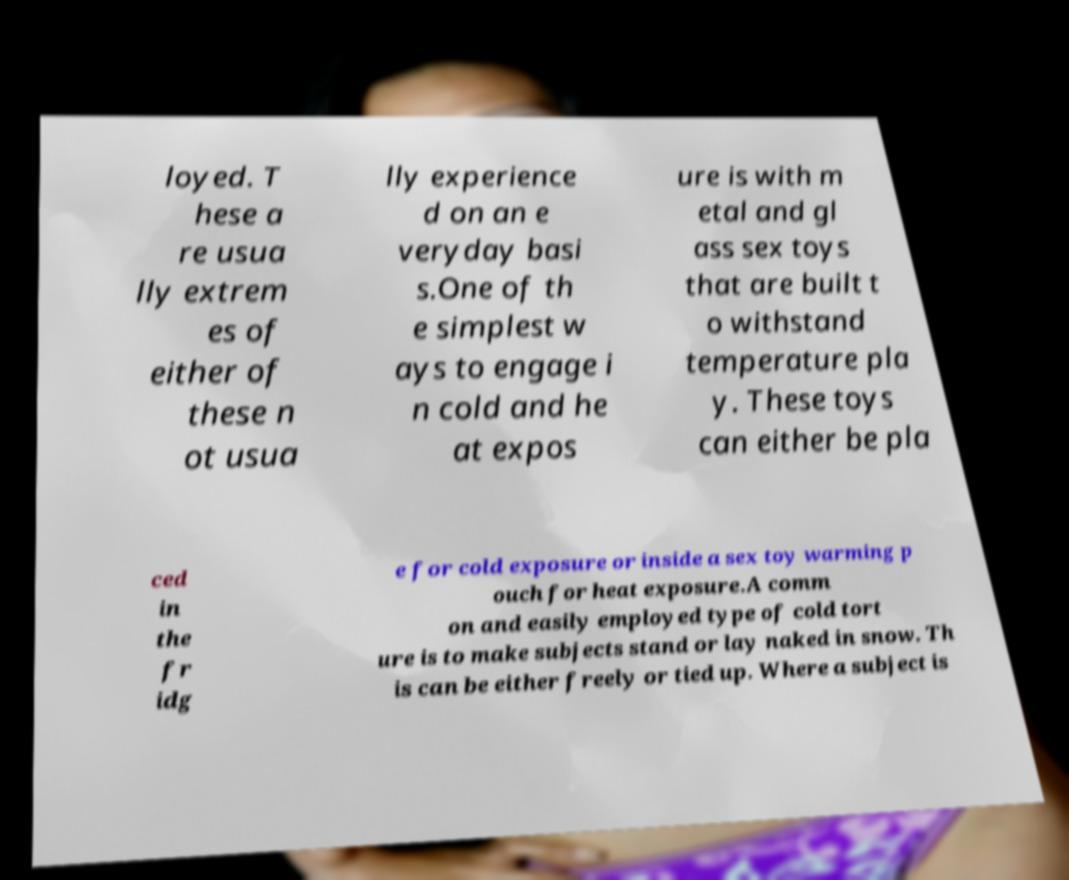I need the written content from this picture converted into text. Can you do that? loyed. T hese a re usua lly extrem es of either of these n ot usua lly experience d on an e veryday basi s.One of th e simplest w ays to engage i n cold and he at expos ure is with m etal and gl ass sex toys that are built t o withstand temperature pla y. These toys can either be pla ced in the fr idg e for cold exposure or inside a sex toy warming p ouch for heat exposure.A comm on and easily employed type of cold tort ure is to make subjects stand or lay naked in snow. Th is can be either freely or tied up. Where a subject is 